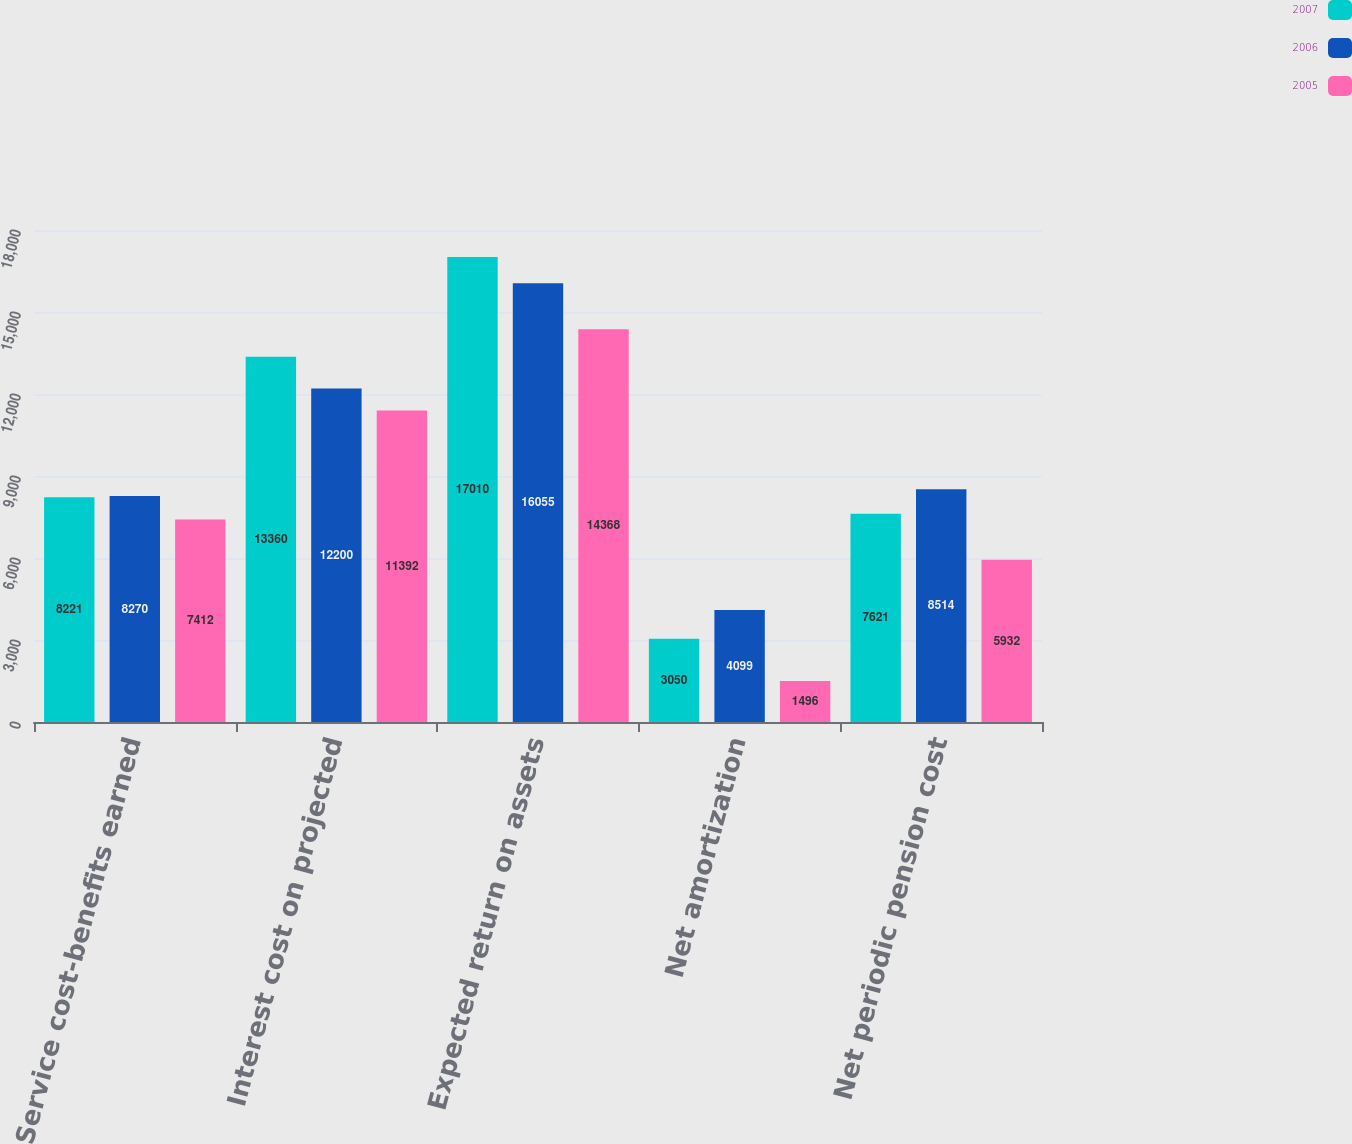Convert chart. <chart><loc_0><loc_0><loc_500><loc_500><stacked_bar_chart><ecel><fcel>Service cost-benefits earned<fcel>Interest cost on projected<fcel>Expected return on assets<fcel>Net amortization<fcel>Net periodic pension cost<nl><fcel>2007<fcel>8221<fcel>13360<fcel>17010<fcel>3050<fcel>7621<nl><fcel>2006<fcel>8270<fcel>12200<fcel>16055<fcel>4099<fcel>8514<nl><fcel>2005<fcel>7412<fcel>11392<fcel>14368<fcel>1496<fcel>5932<nl></chart> 